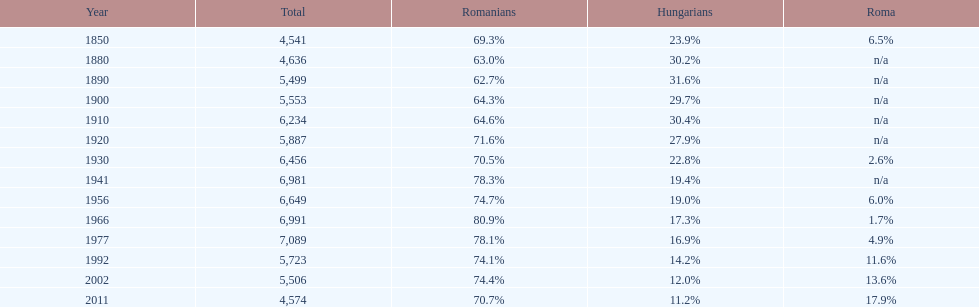In which year was the highest proportion of hungarians observed? 1890. Write the full table. {'header': ['Year', 'Total', 'Romanians', 'Hungarians', 'Roma'], 'rows': [['1850', '4,541', '69.3%', '23.9%', '6.5%'], ['1880', '4,636', '63.0%', '30.2%', 'n/a'], ['1890', '5,499', '62.7%', '31.6%', 'n/a'], ['1900', '5,553', '64.3%', '29.7%', 'n/a'], ['1910', '6,234', '64.6%', '30.4%', 'n/a'], ['1920', '5,887', '71.6%', '27.9%', 'n/a'], ['1930', '6,456', '70.5%', '22.8%', '2.6%'], ['1941', '6,981', '78.3%', '19.4%', 'n/a'], ['1956', '6,649', '74.7%', '19.0%', '6.0%'], ['1966', '6,991', '80.9%', '17.3%', '1.7%'], ['1977', '7,089', '78.1%', '16.9%', '4.9%'], ['1992', '5,723', '74.1%', '14.2%', '11.6%'], ['2002', '5,506', '74.4%', '12.0%', '13.6%'], ['2011', '4,574', '70.7%', '11.2%', '17.9%']]} 